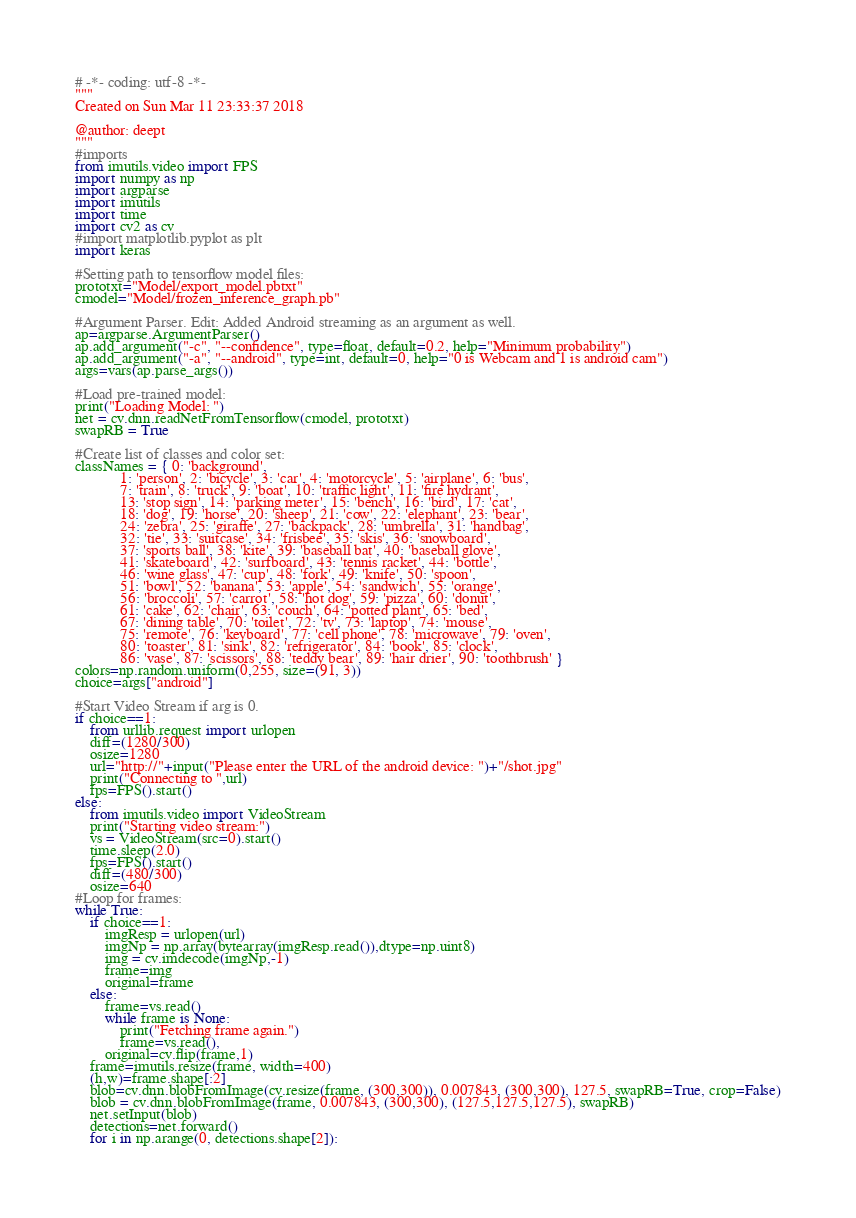Convert code to text. <code><loc_0><loc_0><loc_500><loc_500><_Python_># -*- coding: utf-8 -*-
"""
Created on Sun Mar 11 23:33:37 2018

@author: deept
"""
#imports
from imutils.video import FPS
import numpy as np
import argparse
import imutils
import time
import cv2 as cv
#import matplotlib.pyplot as plt
import keras

#Setting path to tensorflow model files: 
prototxt="Model/export_model.pbtxt"
cmodel="Model/frozen_inference_graph.pb"

#Argument Parser. Edit: Added Android streaming as an argument as well.
ap=argparse.ArgumentParser()
ap.add_argument("-c", "--confidence", type=float, default=0.2, help="Minimum probability")
ap.add_argument("-a", "--android", type=int, default=0, help="0 is Webcam and 1 is android cam")
args=vars(ap.parse_args())

#Load pre-trained model:
print("Loading Model: ")
net = cv.dnn.readNetFromTensorflow(cmodel, prototxt)
swapRB = True

#Create list of classes and color set:
classNames = { 0: 'background',
            1: 'person', 2: 'bicycle', 3: 'car', 4: 'motorcycle', 5: 'airplane', 6: 'bus',
            7: 'train', 8: 'truck', 9: 'boat', 10: 'traffic light', 11: 'fire hydrant',
            13: 'stop sign', 14: 'parking meter', 15: 'bench', 16: 'bird', 17: 'cat',
            18: 'dog', 19: 'horse', 20: 'sheep', 21: 'cow', 22: 'elephant', 23: 'bear',
            24: 'zebra', 25: 'giraffe', 27: 'backpack', 28: 'umbrella', 31: 'handbag',
            32: 'tie', 33: 'suitcase', 34: 'frisbee', 35: 'skis', 36: 'snowboard',
            37: 'sports ball', 38: 'kite', 39: 'baseball bat', 40: 'baseball glove',
            41: 'skateboard', 42: 'surfboard', 43: 'tennis racket', 44: 'bottle',
            46: 'wine glass', 47: 'cup', 48: 'fork', 49: 'knife', 50: 'spoon',
            51: 'bowl', 52: 'banana', 53: 'apple', 54: 'sandwich', 55: 'orange',
            56: 'broccoli', 57: 'carrot', 58: 'hot dog', 59: 'pizza', 60: 'donut',
            61: 'cake', 62: 'chair', 63: 'couch', 64: 'potted plant', 65: 'bed',
            67: 'dining table', 70: 'toilet', 72: 'tv', 73: 'laptop', 74: 'mouse',
            75: 'remote', 76: 'keyboard', 77: 'cell phone', 78: 'microwave', 79: 'oven',
            80: 'toaster', 81: 'sink', 82: 'refrigerator', 84: 'book', 85: 'clock',
            86: 'vase', 87: 'scissors', 88: 'teddy bear', 89: 'hair drier', 90: 'toothbrush' }
colors=np.random.uniform(0,255, size=(91, 3))
choice=args["android"]

#Start Video Stream if arg is 0.
if choice==1:
    from urllib.request import urlopen
    diff=(1280/300)
    osize=1280
    url="http://"+input("Please enter the URL of the android device: ")+"/shot.jpg"
    print("Connecting to ",url)
    fps=FPS().start()
else:
    from imutils.video import VideoStream
    print("Starting video stream:")
    vs = VideoStream(src=0).start()
    time.sleep(2.0)
    fps=FPS().start()
    diff=(480/300)
    osize=640
#Loop for frames:
while True:
    if choice==1:
        imgResp = urlopen(url)
        imgNp = np.array(bytearray(imgResp.read()),dtype=np.uint8)
        img = cv.imdecode(imgNp,-1)
        frame=img
        original=frame
    else:
        frame=vs.read()
        while frame is None:
            print("Fetching frame again.")
            frame=vs.read(),
        original=cv.flip(frame,1)
    frame=imutils.resize(frame, width=400)
    (h,w)=frame.shape[:2]
    blob=cv.dnn.blobFromImage(cv.resize(frame, (300,300)), 0.007843, (300,300), 127.5, swapRB=True, crop=False)
    blob = cv.dnn.blobFromImage(frame, 0.007843, (300,300), (127.5,127.5,127.5), swapRB)
    net.setInput(blob)
    detections=net.forward()
    for i in np.arange(0, detections.shape[2]):</code> 